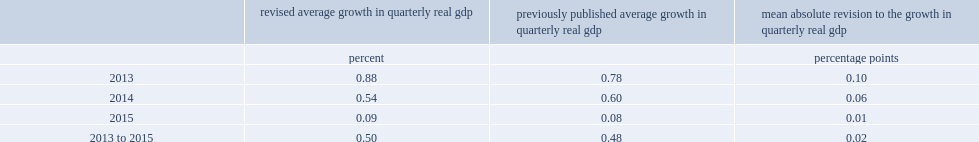What was the mean absolute percentage point revision to the quarterly growth rate in real gdp from 2013 to 2015? 0.02. 